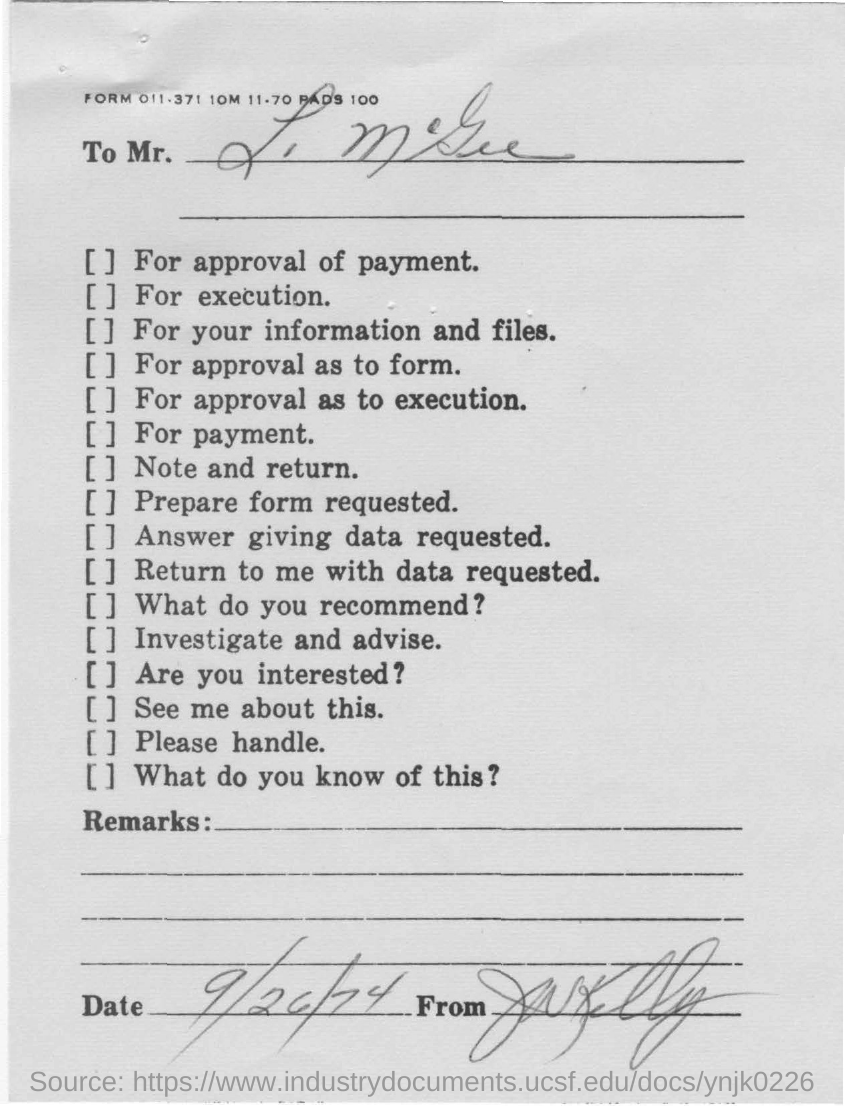What date is given?
Your answer should be compact. 9/26/74. 